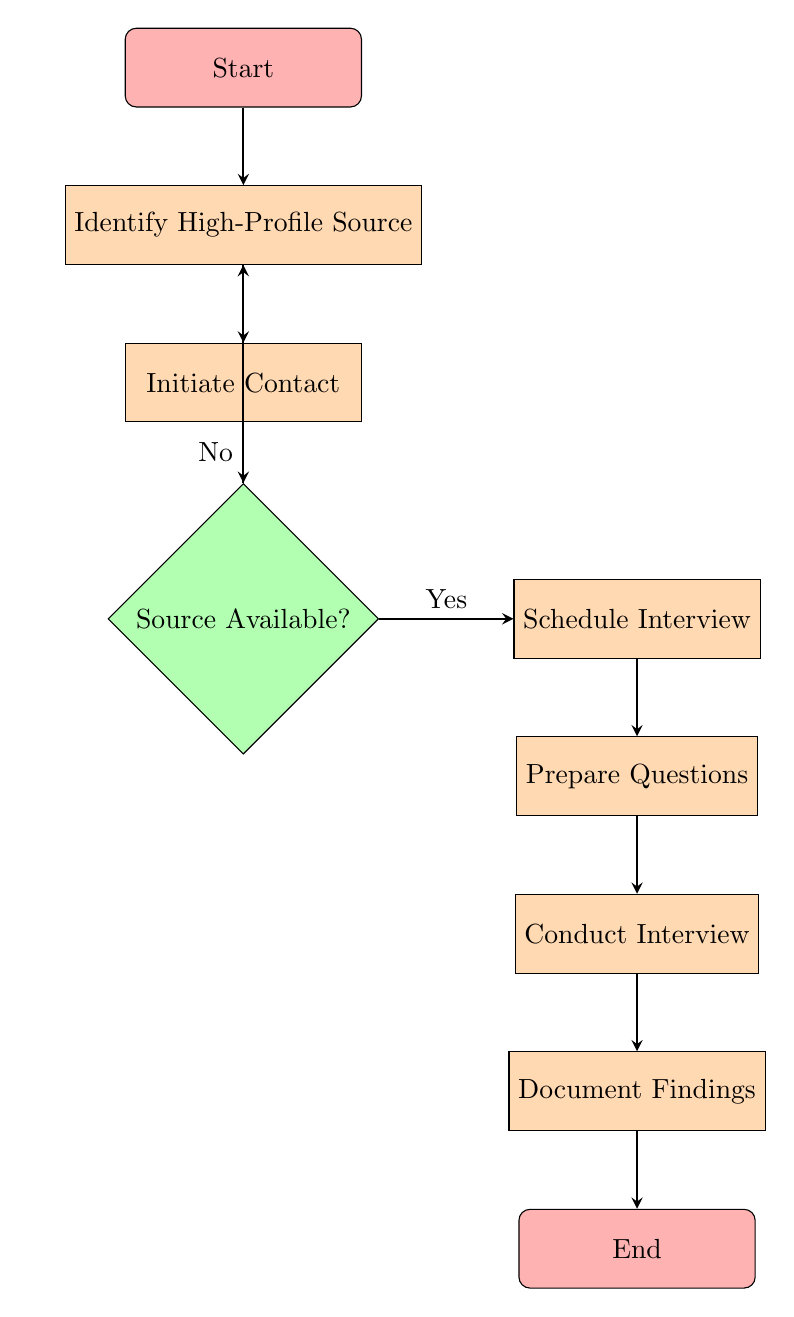What is the first step in the workflow? The first step is "Start," which initiates the workflow for setting up the interview.
Answer: Start How many decision nodes are present in the diagram? There is one decision node labeled "Source Available?" which requires a yes or no response to move forward in the process.
Answer: 1 What happens if the source is not available? If the source is not available, the flowchart indicates to return to the "Identify High-Profile Source" step, suggesting a retry or selecting an alternate source.
Answer: Retry or alternate What is the last action taken before ending the workflow? The last action before reaching the "End" node is "Document Findings," which entails recording and transcribing key points from the interview.
Answer: Document Findings What is the connection between "Prepare Questions" and "Conduct Interview"? "Prepare Questions" directly precedes "Conduct Interview" and represents the preparation step that must be completed before conducting the actual interview.
Answer: Conduct Interview What is the relationship between "Initiate Contact" and "Confirm Availability"? "Initiate Contact" leads directly to "Confirm Availability," which is a decision point that assesses if the high-profile source is available for an interview.
Answer: Confirm Availability Explain the process that occurs after scheduling the interview. After scheduling the interview, the next step is to prepare questions, ensuring they are relevant and engaging, which prepares the journalist for a successful interview.
Answer: Prepare Questions What medium can be selected for the interview? The medium for the interview can be either in-person or virtual, as indicated in the "Schedule Interview" step, where the details are agreed upon.
Answer: In-person/virtual 